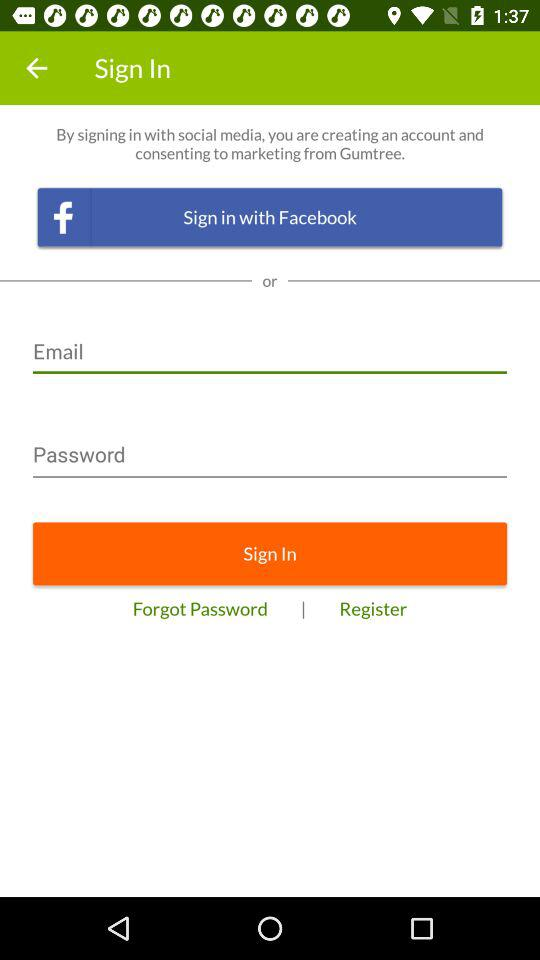How many characters are required to create a password?
When the provided information is insufficient, respond with <no answer>. <no answer> 